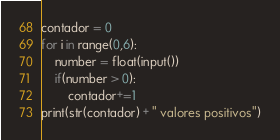Convert code to text. <code><loc_0><loc_0><loc_500><loc_500><_Python_>contador = 0
for i in range(0,6):
	number = float(input())
	if(number > 0):
		contador+=1
print(str(contador) + " valores positivos")
</code> 